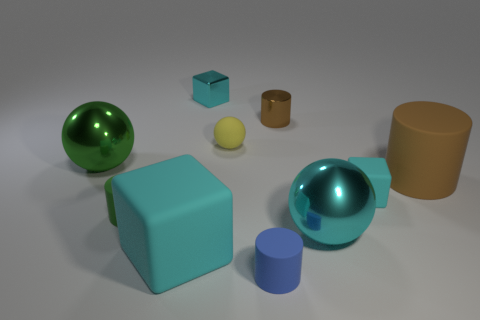What number of other objects are there of the same color as the shiny cube?
Keep it short and to the point. 3. Is there a cyan metal block?
Your response must be concise. Yes. The cyan thing that is behind the tiny green matte cylinder and in front of the cyan metal block has what shape?
Your response must be concise. Cube. What size is the metal sphere that is on the left side of the large cube?
Your answer should be compact. Large. Does the large metal ball that is behind the big brown cylinder have the same color as the tiny rubber block?
Provide a succinct answer. No. What number of small yellow objects have the same shape as the large cyan metallic thing?
Your answer should be very brief. 1. What number of objects are cylinders behind the big brown object or cylinders behind the large green shiny sphere?
Provide a succinct answer. 1. What number of gray objects are either tiny rubber balls or big cylinders?
Offer a terse response. 0. What is the cyan cube that is both to the left of the yellow object and in front of the small brown shiny cylinder made of?
Keep it short and to the point. Rubber. Is the yellow thing made of the same material as the big cyan cube?
Offer a terse response. Yes. 